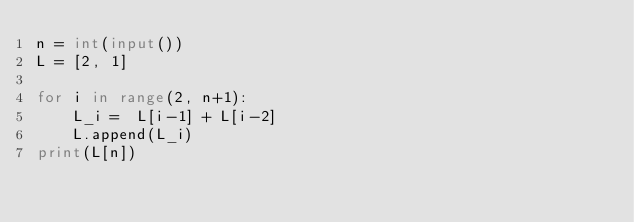Convert code to text. <code><loc_0><loc_0><loc_500><loc_500><_Python_>n = int(input())
L = [2, 1]

for i in range(2, n+1):
    L_i =  L[i-1] + L[i-2]
    L.append(L_i)
print(L[n])</code> 